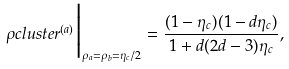Convert formula to latex. <formula><loc_0><loc_0><loc_500><loc_500>\rho c l u s t e r ^ { ( a ) } \Big | _ { \rho _ { a } = \rho _ { b } = \eta _ { c } / 2 } = \frac { ( 1 - \eta _ { c } ) ( 1 - d \eta _ { c } ) } { 1 + d ( 2 d - 3 ) \eta _ { c } } ,</formula> 